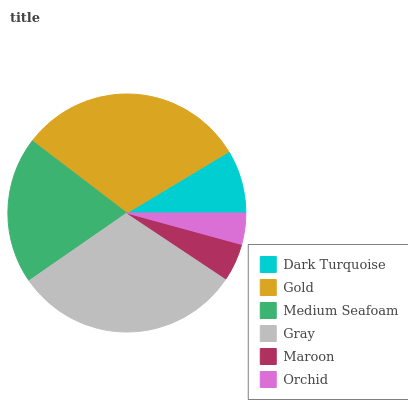Is Orchid the minimum?
Answer yes or no. Yes. Is Gold the maximum?
Answer yes or no. Yes. Is Medium Seafoam the minimum?
Answer yes or no. No. Is Medium Seafoam the maximum?
Answer yes or no. No. Is Gold greater than Medium Seafoam?
Answer yes or no. Yes. Is Medium Seafoam less than Gold?
Answer yes or no. Yes. Is Medium Seafoam greater than Gold?
Answer yes or no. No. Is Gold less than Medium Seafoam?
Answer yes or no. No. Is Medium Seafoam the high median?
Answer yes or no. Yes. Is Dark Turquoise the low median?
Answer yes or no. Yes. Is Dark Turquoise the high median?
Answer yes or no. No. Is Maroon the low median?
Answer yes or no. No. 